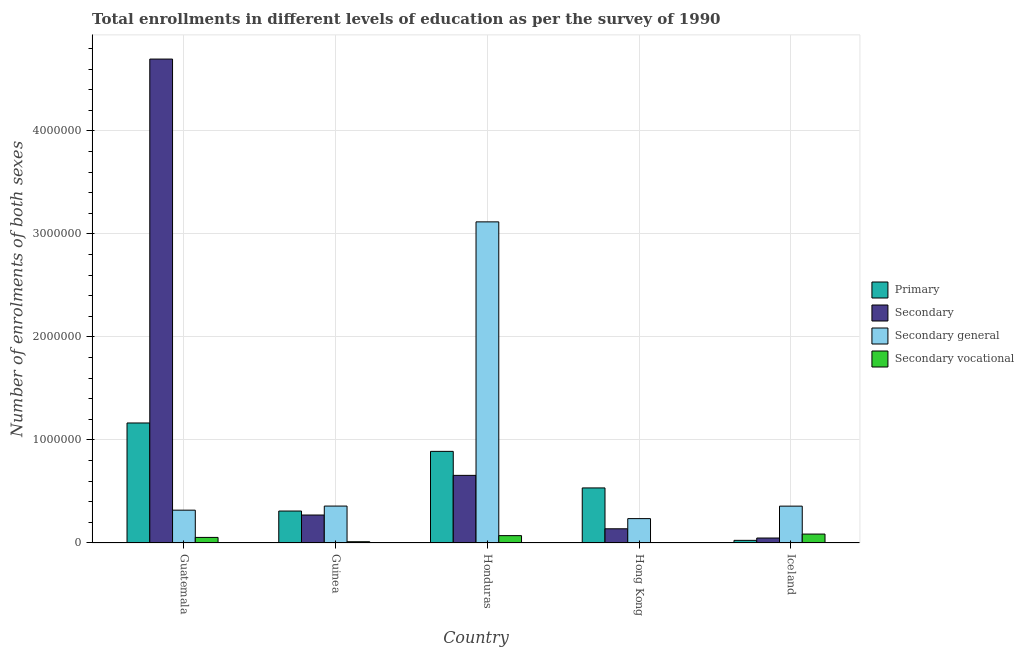How many groups of bars are there?
Provide a succinct answer. 5. Are the number of bars per tick equal to the number of legend labels?
Your response must be concise. Yes. Are the number of bars on each tick of the X-axis equal?
Make the answer very short. Yes. How many bars are there on the 1st tick from the left?
Keep it short and to the point. 4. How many bars are there on the 3rd tick from the right?
Offer a terse response. 4. What is the label of the 2nd group of bars from the left?
Your answer should be compact. Guinea. What is the number of enrolments in secondary education in Honduras?
Your response must be concise. 6.56e+05. Across all countries, what is the maximum number of enrolments in primary education?
Give a very brief answer. 1.16e+06. Across all countries, what is the minimum number of enrolments in secondary education?
Keep it short and to the point. 4.82e+04. In which country was the number of enrolments in secondary education maximum?
Keep it short and to the point. Guatemala. In which country was the number of enrolments in secondary vocational education minimum?
Provide a short and direct response. Hong Kong. What is the total number of enrolments in secondary education in the graph?
Provide a succinct answer. 5.81e+06. What is the difference between the number of enrolments in secondary education in Guatemala and that in Iceland?
Offer a very short reply. 4.65e+06. What is the difference between the number of enrolments in primary education in Honduras and the number of enrolments in secondary general education in Iceland?
Your answer should be compact. 5.32e+05. What is the average number of enrolments in secondary vocational education per country?
Give a very brief answer. 4.52e+04. What is the difference between the number of enrolments in secondary vocational education and number of enrolments in secondary general education in Guatemala?
Provide a succinct answer. -2.65e+05. What is the ratio of the number of enrolments in primary education in Guinea to that in Iceland?
Provide a short and direct response. 12.15. Is the difference between the number of enrolments in primary education in Honduras and Iceland greater than the difference between the number of enrolments in secondary vocational education in Honduras and Iceland?
Your answer should be very brief. Yes. What is the difference between the highest and the second highest number of enrolments in secondary general education?
Give a very brief answer. 2.76e+06. What is the difference between the highest and the lowest number of enrolments in secondary education?
Your response must be concise. 4.65e+06. Is the sum of the number of enrolments in secondary vocational education in Honduras and Hong Kong greater than the maximum number of enrolments in primary education across all countries?
Ensure brevity in your answer.  No. What does the 2nd bar from the left in Iceland represents?
Make the answer very short. Secondary. What does the 4th bar from the right in Honduras represents?
Offer a terse response. Primary. How many bars are there?
Your answer should be compact. 20. Does the graph contain grids?
Offer a very short reply. Yes. Where does the legend appear in the graph?
Your answer should be very brief. Center right. What is the title of the graph?
Keep it short and to the point. Total enrollments in different levels of education as per the survey of 1990. What is the label or title of the X-axis?
Your answer should be very brief. Country. What is the label or title of the Y-axis?
Keep it short and to the point. Number of enrolments of both sexes. What is the Number of enrolments of both sexes of Primary in Guatemala?
Keep it short and to the point. 1.16e+06. What is the Number of enrolments of both sexes of Secondary in Guatemala?
Give a very brief answer. 4.70e+06. What is the Number of enrolments of both sexes of Secondary general in Guatemala?
Your answer should be compact. 3.19e+05. What is the Number of enrolments of both sexes of Secondary vocational in Guatemala?
Provide a succinct answer. 5.41e+04. What is the Number of enrolments of both sexes in Primary in Guinea?
Your answer should be very brief. 3.10e+05. What is the Number of enrolments of both sexes in Secondary in Guinea?
Offer a very short reply. 2.71e+05. What is the Number of enrolments of both sexes in Secondary general in Guinea?
Your answer should be compact. 3.58e+05. What is the Number of enrolments of both sexes of Secondary vocational in Guinea?
Offer a terse response. 1.23e+04. What is the Number of enrolments of both sexes of Primary in Honduras?
Offer a very short reply. 8.89e+05. What is the Number of enrolments of both sexes of Secondary in Honduras?
Make the answer very short. 6.56e+05. What is the Number of enrolments of both sexes in Secondary general in Honduras?
Your response must be concise. 3.12e+06. What is the Number of enrolments of both sexes of Secondary vocational in Honduras?
Your answer should be compact. 7.14e+04. What is the Number of enrolments of both sexes in Primary in Hong Kong?
Provide a succinct answer. 5.34e+05. What is the Number of enrolments of both sexes in Secondary in Hong Kong?
Offer a terse response. 1.38e+05. What is the Number of enrolments of both sexes in Secondary general in Hong Kong?
Provide a succinct answer. 2.37e+05. What is the Number of enrolments of both sexes in Secondary vocational in Hong Kong?
Give a very brief answer. 1906. What is the Number of enrolments of both sexes of Primary in Iceland?
Make the answer very short. 2.55e+04. What is the Number of enrolments of both sexes of Secondary in Iceland?
Offer a terse response. 4.82e+04. What is the Number of enrolments of both sexes of Secondary general in Iceland?
Your answer should be very brief. 3.58e+05. What is the Number of enrolments of both sexes in Secondary vocational in Iceland?
Ensure brevity in your answer.  8.66e+04. Across all countries, what is the maximum Number of enrolments of both sexes in Primary?
Offer a very short reply. 1.16e+06. Across all countries, what is the maximum Number of enrolments of both sexes of Secondary?
Provide a short and direct response. 4.70e+06. Across all countries, what is the maximum Number of enrolments of both sexes of Secondary general?
Your response must be concise. 3.12e+06. Across all countries, what is the maximum Number of enrolments of both sexes of Secondary vocational?
Ensure brevity in your answer.  8.66e+04. Across all countries, what is the minimum Number of enrolments of both sexes in Primary?
Provide a short and direct response. 2.55e+04. Across all countries, what is the minimum Number of enrolments of both sexes of Secondary?
Your answer should be compact. 4.82e+04. Across all countries, what is the minimum Number of enrolments of both sexes in Secondary general?
Make the answer very short. 2.37e+05. Across all countries, what is the minimum Number of enrolments of both sexes of Secondary vocational?
Provide a short and direct response. 1906. What is the total Number of enrolments of both sexes of Primary in the graph?
Give a very brief answer. 2.92e+06. What is the total Number of enrolments of both sexes of Secondary in the graph?
Ensure brevity in your answer.  5.81e+06. What is the total Number of enrolments of both sexes in Secondary general in the graph?
Give a very brief answer. 4.39e+06. What is the total Number of enrolments of both sexes in Secondary vocational in the graph?
Provide a short and direct response. 2.26e+05. What is the difference between the Number of enrolments of both sexes in Primary in Guatemala and that in Guinea?
Your answer should be very brief. 8.55e+05. What is the difference between the Number of enrolments of both sexes of Secondary in Guatemala and that in Guinea?
Provide a short and direct response. 4.43e+06. What is the difference between the Number of enrolments of both sexes of Secondary general in Guatemala and that in Guinea?
Provide a short and direct response. -3.98e+04. What is the difference between the Number of enrolments of both sexes of Secondary vocational in Guatemala and that in Guinea?
Your answer should be compact. 4.18e+04. What is the difference between the Number of enrolments of both sexes in Primary in Guatemala and that in Honduras?
Provide a succinct answer. 2.76e+05. What is the difference between the Number of enrolments of both sexes of Secondary in Guatemala and that in Honduras?
Ensure brevity in your answer.  4.04e+06. What is the difference between the Number of enrolments of both sexes of Secondary general in Guatemala and that in Honduras?
Provide a short and direct response. -2.80e+06. What is the difference between the Number of enrolments of both sexes of Secondary vocational in Guatemala and that in Honduras?
Provide a succinct answer. -1.73e+04. What is the difference between the Number of enrolments of both sexes of Primary in Guatemala and that in Hong Kong?
Your response must be concise. 6.30e+05. What is the difference between the Number of enrolments of both sexes in Secondary in Guatemala and that in Hong Kong?
Your answer should be very brief. 4.56e+06. What is the difference between the Number of enrolments of both sexes of Secondary general in Guatemala and that in Hong Kong?
Keep it short and to the point. 8.20e+04. What is the difference between the Number of enrolments of both sexes of Secondary vocational in Guatemala and that in Hong Kong?
Offer a terse response. 5.22e+04. What is the difference between the Number of enrolments of both sexes in Primary in Guatemala and that in Iceland?
Make the answer very short. 1.14e+06. What is the difference between the Number of enrolments of both sexes of Secondary in Guatemala and that in Iceland?
Your answer should be very brief. 4.65e+06. What is the difference between the Number of enrolments of both sexes of Secondary general in Guatemala and that in Iceland?
Provide a short and direct response. -3.92e+04. What is the difference between the Number of enrolments of both sexes in Secondary vocational in Guatemala and that in Iceland?
Offer a very short reply. -3.25e+04. What is the difference between the Number of enrolments of both sexes in Primary in Guinea and that in Honduras?
Your answer should be very brief. -5.79e+05. What is the difference between the Number of enrolments of both sexes of Secondary in Guinea and that in Honduras?
Offer a terse response. -3.85e+05. What is the difference between the Number of enrolments of both sexes of Secondary general in Guinea and that in Honduras?
Keep it short and to the point. -2.76e+06. What is the difference between the Number of enrolments of both sexes of Secondary vocational in Guinea and that in Honduras?
Provide a succinct answer. -5.91e+04. What is the difference between the Number of enrolments of both sexes of Primary in Guinea and that in Hong Kong?
Your response must be concise. -2.24e+05. What is the difference between the Number of enrolments of both sexes in Secondary in Guinea and that in Hong Kong?
Offer a terse response. 1.34e+05. What is the difference between the Number of enrolments of both sexes of Secondary general in Guinea and that in Hong Kong?
Your response must be concise. 1.22e+05. What is the difference between the Number of enrolments of both sexes of Secondary vocational in Guinea and that in Hong Kong?
Make the answer very short. 1.04e+04. What is the difference between the Number of enrolments of both sexes of Primary in Guinea and that in Iceland?
Offer a terse response. 2.85e+05. What is the difference between the Number of enrolments of both sexes of Secondary in Guinea and that in Iceland?
Provide a short and direct response. 2.23e+05. What is the difference between the Number of enrolments of both sexes of Secondary general in Guinea and that in Iceland?
Provide a succinct answer. 657. What is the difference between the Number of enrolments of both sexes of Secondary vocational in Guinea and that in Iceland?
Offer a terse response. -7.43e+04. What is the difference between the Number of enrolments of both sexes of Primary in Honduras and that in Hong Kong?
Ensure brevity in your answer.  3.55e+05. What is the difference between the Number of enrolments of both sexes of Secondary in Honduras and that in Hong Kong?
Provide a succinct answer. 5.19e+05. What is the difference between the Number of enrolments of both sexes in Secondary general in Honduras and that in Hong Kong?
Make the answer very short. 2.88e+06. What is the difference between the Number of enrolments of both sexes of Secondary vocational in Honduras and that in Hong Kong?
Give a very brief answer. 6.95e+04. What is the difference between the Number of enrolments of both sexes in Primary in Honduras and that in Iceland?
Provide a succinct answer. 8.64e+05. What is the difference between the Number of enrolments of both sexes of Secondary in Honduras and that in Iceland?
Make the answer very short. 6.08e+05. What is the difference between the Number of enrolments of both sexes of Secondary general in Honduras and that in Iceland?
Offer a very short reply. 2.76e+06. What is the difference between the Number of enrolments of both sexes in Secondary vocational in Honduras and that in Iceland?
Offer a terse response. -1.52e+04. What is the difference between the Number of enrolments of both sexes in Primary in Hong Kong and that in Iceland?
Provide a short and direct response. 5.09e+05. What is the difference between the Number of enrolments of both sexes of Secondary in Hong Kong and that in Iceland?
Give a very brief answer. 8.97e+04. What is the difference between the Number of enrolments of both sexes of Secondary general in Hong Kong and that in Iceland?
Make the answer very short. -1.21e+05. What is the difference between the Number of enrolments of both sexes of Secondary vocational in Hong Kong and that in Iceland?
Give a very brief answer. -8.47e+04. What is the difference between the Number of enrolments of both sexes in Primary in Guatemala and the Number of enrolments of both sexes in Secondary in Guinea?
Make the answer very short. 8.94e+05. What is the difference between the Number of enrolments of both sexes of Primary in Guatemala and the Number of enrolments of both sexes of Secondary general in Guinea?
Keep it short and to the point. 8.07e+05. What is the difference between the Number of enrolments of both sexes of Primary in Guatemala and the Number of enrolments of both sexes of Secondary vocational in Guinea?
Your answer should be compact. 1.15e+06. What is the difference between the Number of enrolments of both sexes in Secondary in Guatemala and the Number of enrolments of both sexes in Secondary general in Guinea?
Give a very brief answer. 4.34e+06. What is the difference between the Number of enrolments of both sexes in Secondary in Guatemala and the Number of enrolments of both sexes in Secondary vocational in Guinea?
Your answer should be compact. 4.69e+06. What is the difference between the Number of enrolments of both sexes of Secondary general in Guatemala and the Number of enrolments of both sexes of Secondary vocational in Guinea?
Ensure brevity in your answer.  3.06e+05. What is the difference between the Number of enrolments of both sexes in Primary in Guatemala and the Number of enrolments of both sexes in Secondary in Honduras?
Ensure brevity in your answer.  5.09e+05. What is the difference between the Number of enrolments of both sexes of Primary in Guatemala and the Number of enrolments of both sexes of Secondary general in Honduras?
Ensure brevity in your answer.  -1.95e+06. What is the difference between the Number of enrolments of both sexes of Primary in Guatemala and the Number of enrolments of both sexes of Secondary vocational in Honduras?
Keep it short and to the point. 1.09e+06. What is the difference between the Number of enrolments of both sexes in Secondary in Guatemala and the Number of enrolments of both sexes in Secondary general in Honduras?
Your response must be concise. 1.58e+06. What is the difference between the Number of enrolments of both sexes in Secondary in Guatemala and the Number of enrolments of both sexes in Secondary vocational in Honduras?
Offer a terse response. 4.63e+06. What is the difference between the Number of enrolments of both sexes of Secondary general in Guatemala and the Number of enrolments of both sexes of Secondary vocational in Honduras?
Offer a very short reply. 2.47e+05. What is the difference between the Number of enrolments of both sexes of Primary in Guatemala and the Number of enrolments of both sexes of Secondary in Hong Kong?
Give a very brief answer. 1.03e+06. What is the difference between the Number of enrolments of both sexes of Primary in Guatemala and the Number of enrolments of both sexes of Secondary general in Hong Kong?
Provide a short and direct response. 9.28e+05. What is the difference between the Number of enrolments of both sexes in Primary in Guatemala and the Number of enrolments of both sexes in Secondary vocational in Hong Kong?
Make the answer very short. 1.16e+06. What is the difference between the Number of enrolments of both sexes of Secondary in Guatemala and the Number of enrolments of both sexes of Secondary general in Hong Kong?
Offer a very short reply. 4.46e+06. What is the difference between the Number of enrolments of both sexes of Secondary in Guatemala and the Number of enrolments of both sexes of Secondary vocational in Hong Kong?
Provide a succinct answer. 4.70e+06. What is the difference between the Number of enrolments of both sexes in Secondary general in Guatemala and the Number of enrolments of both sexes in Secondary vocational in Hong Kong?
Your response must be concise. 3.17e+05. What is the difference between the Number of enrolments of both sexes of Primary in Guatemala and the Number of enrolments of both sexes of Secondary in Iceland?
Provide a short and direct response. 1.12e+06. What is the difference between the Number of enrolments of both sexes of Primary in Guatemala and the Number of enrolments of both sexes of Secondary general in Iceland?
Make the answer very short. 8.07e+05. What is the difference between the Number of enrolments of both sexes of Primary in Guatemala and the Number of enrolments of both sexes of Secondary vocational in Iceland?
Keep it short and to the point. 1.08e+06. What is the difference between the Number of enrolments of both sexes in Secondary in Guatemala and the Number of enrolments of both sexes in Secondary general in Iceland?
Your answer should be very brief. 4.34e+06. What is the difference between the Number of enrolments of both sexes in Secondary in Guatemala and the Number of enrolments of both sexes in Secondary vocational in Iceland?
Offer a very short reply. 4.61e+06. What is the difference between the Number of enrolments of both sexes of Secondary general in Guatemala and the Number of enrolments of both sexes of Secondary vocational in Iceland?
Your response must be concise. 2.32e+05. What is the difference between the Number of enrolments of both sexes of Primary in Guinea and the Number of enrolments of both sexes of Secondary in Honduras?
Provide a short and direct response. -3.46e+05. What is the difference between the Number of enrolments of both sexes in Primary in Guinea and the Number of enrolments of both sexes in Secondary general in Honduras?
Make the answer very short. -2.81e+06. What is the difference between the Number of enrolments of both sexes of Primary in Guinea and the Number of enrolments of both sexes of Secondary vocational in Honduras?
Give a very brief answer. 2.39e+05. What is the difference between the Number of enrolments of both sexes in Secondary in Guinea and the Number of enrolments of both sexes in Secondary general in Honduras?
Your answer should be very brief. -2.85e+06. What is the difference between the Number of enrolments of both sexes of Secondary in Guinea and the Number of enrolments of both sexes of Secondary vocational in Honduras?
Provide a succinct answer. 2.00e+05. What is the difference between the Number of enrolments of both sexes in Secondary general in Guinea and the Number of enrolments of both sexes in Secondary vocational in Honduras?
Your answer should be very brief. 2.87e+05. What is the difference between the Number of enrolments of both sexes of Primary in Guinea and the Number of enrolments of both sexes of Secondary in Hong Kong?
Your answer should be very brief. 1.72e+05. What is the difference between the Number of enrolments of both sexes in Primary in Guinea and the Number of enrolments of both sexes in Secondary general in Hong Kong?
Make the answer very short. 7.35e+04. What is the difference between the Number of enrolments of both sexes of Primary in Guinea and the Number of enrolments of both sexes of Secondary vocational in Hong Kong?
Give a very brief answer. 3.08e+05. What is the difference between the Number of enrolments of both sexes in Secondary in Guinea and the Number of enrolments of both sexes in Secondary general in Hong Kong?
Your answer should be compact. 3.48e+04. What is the difference between the Number of enrolments of both sexes of Secondary in Guinea and the Number of enrolments of both sexes of Secondary vocational in Hong Kong?
Ensure brevity in your answer.  2.70e+05. What is the difference between the Number of enrolments of both sexes of Secondary general in Guinea and the Number of enrolments of both sexes of Secondary vocational in Hong Kong?
Make the answer very short. 3.57e+05. What is the difference between the Number of enrolments of both sexes of Primary in Guinea and the Number of enrolments of both sexes of Secondary in Iceland?
Your response must be concise. 2.62e+05. What is the difference between the Number of enrolments of both sexes in Primary in Guinea and the Number of enrolments of both sexes in Secondary general in Iceland?
Give a very brief answer. -4.77e+04. What is the difference between the Number of enrolments of both sexes in Primary in Guinea and the Number of enrolments of both sexes in Secondary vocational in Iceland?
Offer a terse response. 2.23e+05. What is the difference between the Number of enrolments of both sexes of Secondary in Guinea and the Number of enrolments of both sexes of Secondary general in Iceland?
Your answer should be compact. -8.63e+04. What is the difference between the Number of enrolments of both sexes of Secondary in Guinea and the Number of enrolments of both sexes of Secondary vocational in Iceland?
Give a very brief answer. 1.85e+05. What is the difference between the Number of enrolments of both sexes of Secondary general in Guinea and the Number of enrolments of both sexes of Secondary vocational in Iceland?
Provide a short and direct response. 2.72e+05. What is the difference between the Number of enrolments of both sexes in Primary in Honduras and the Number of enrolments of both sexes in Secondary in Hong Kong?
Make the answer very short. 7.51e+05. What is the difference between the Number of enrolments of both sexes in Primary in Honduras and the Number of enrolments of both sexes in Secondary general in Hong Kong?
Provide a succinct answer. 6.53e+05. What is the difference between the Number of enrolments of both sexes in Primary in Honduras and the Number of enrolments of both sexes in Secondary vocational in Hong Kong?
Offer a terse response. 8.87e+05. What is the difference between the Number of enrolments of both sexes of Secondary in Honduras and the Number of enrolments of both sexes of Secondary general in Hong Kong?
Give a very brief answer. 4.20e+05. What is the difference between the Number of enrolments of both sexes in Secondary in Honduras and the Number of enrolments of both sexes in Secondary vocational in Hong Kong?
Ensure brevity in your answer.  6.54e+05. What is the difference between the Number of enrolments of both sexes of Secondary general in Honduras and the Number of enrolments of both sexes of Secondary vocational in Hong Kong?
Offer a very short reply. 3.12e+06. What is the difference between the Number of enrolments of both sexes in Primary in Honduras and the Number of enrolments of both sexes in Secondary in Iceland?
Ensure brevity in your answer.  8.41e+05. What is the difference between the Number of enrolments of both sexes of Primary in Honduras and the Number of enrolments of both sexes of Secondary general in Iceland?
Keep it short and to the point. 5.32e+05. What is the difference between the Number of enrolments of both sexes in Primary in Honduras and the Number of enrolments of both sexes in Secondary vocational in Iceland?
Offer a terse response. 8.03e+05. What is the difference between the Number of enrolments of both sexes in Secondary in Honduras and the Number of enrolments of both sexes in Secondary general in Iceland?
Give a very brief answer. 2.99e+05. What is the difference between the Number of enrolments of both sexes of Secondary in Honduras and the Number of enrolments of both sexes of Secondary vocational in Iceland?
Your answer should be very brief. 5.70e+05. What is the difference between the Number of enrolments of both sexes of Secondary general in Honduras and the Number of enrolments of both sexes of Secondary vocational in Iceland?
Offer a very short reply. 3.03e+06. What is the difference between the Number of enrolments of both sexes in Primary in Hong Kong and the Number of enrolments of both sexes in Secondary in Iceland?
Give a very brief answer. 4.86e+05. What is the difference between the Number of enrolments of both sexes in Primary in Hong Kong and the Number of enrolments of both sexes in Secondary general in Iceland?
Make the answer very short. 1.77e+05. What is the difference between the Number of enrolments of both sexes of Primary in Hong Kong and the Number of enrolments of both sexes of Secondary vocational in Iceland?
Ensure brevity in your answer.  4.48e+05. What is the difference between the Number of enrolments of both sexes in Secondary in Hong Kong and the Number of enrolments of both sexes in Secondary general in Iceland?
Your response must be concise. -2.20e+05. What is the difference between the Number of enrolments of both sexes in Secondary in Hong Kong and the Number of enrolments of both sexes in Secondary vocational in Iceland?
Offer a terse response. 5.13e+04. What is the difference between the Number of enrolments of both sexes of Secondary general in Hong Kong and the Number of enrolments of both sexes of Secondary vocational in Iceland?
Keep it short and to the point. 1.50e+05. What is the average Number of enrolments of both sexes in Primary per country?
Provide a succinct answer. 5.85e+05. What is the average Number of enrolments of both sexes in Secondary per country?
Give a very brief answer. 1.16e+06. What is the average Number of enrolments of both sexes of Secondary general per country?
Keep it short and to the point. 8.78e+05. What is the average Number of enrolments of both sexes of Secondary vocational per country?
Offer a very short reply. 4.52e+04. What is the difference between the Number of enrolments of both sexes in Primary and Number of enrolments of both sexes in Secondary in Guatemala?
Keep it short and to the point. -3.53e+06. What is the difference between the Number of enrolments of both sexes in Primary and Number of enrolments of both sexes in Secondary general in Guatemala?
Your answer should be very brief. 8.46e+05. What is the difference between the Number of enrolments of both sexes of Primary and Number of enrolments of both sexes of Secondary vocational in Guatemala?
Ensure brevity in your answer.  1.11e+06. What is the difference between the Number of enrolments of both sexes of Secondary and Number of enrolments of both sexes of Secondary general in Guatemala?
Your response must be concise. 4.38e+06. What is the difference between the Number of enrolments of both sexes in Secondary and Number of enrolments of both sexes in Secondary vocational in Guatemala?
Provide a short and direct response. 4.64e+06. What is the difference between the Number of enrolments of both sexes in Secondary general and Number of enrolments of both sexes in Secondary vocational in Guatemala?
Provide a succinct answer. 2.65e+05. What is the difference between the Number of enrolments of both sexes in Primary and Number of enrolments of both sexes in Secondary in Guinea?
Ensure brevity in your answer.  3.86e+04. What is the difference between the Number of enrolments of both sexes in Primary and Number of enrolments of both sexes in Secondary general in Guinea?
Make the answer very short. -4.83e+04. What is the difference between the Number of enrolments of both sexes in Primary and Number of enrolments of both sexes in Secondary vocational in Guinea?
Ensure brevity in your answer.  2.98e+05. What is the difference between the Number of enrolments of both sexes in Secondary and Number of enrolments of both sexes in Secondary general in Guinea?
Your response must be concise. -8.70e+04. What is the difference between the Number of enrolments of both sexes in Secondary and Number of enrolments of both sexes in Secondary vocational in Guinea?
Offer a terse response. 2.59e+05. What is the difference between the Number of enrolments of both sexes of Secondary general and Number of enrolments of both sexes of Secondary vocational in Guinea?
Make the answer very short. 3.46e+05. What is the difference between the Number of enrolments of both sexes in Primary and Number of enrolments of both sexes in Secondary in Honduras?
Keep it short and to the point. 2.33e+05. What is the difference between the Number of enrolments of both sexes in Primary and Number of enrolments of both sexes in Secondary general in Honduras?
Make the answer very short. -2.23e+06. What is the difference between the Number of enrolments of both sexes in Primary and Number of enrolments of both sexes in Secondary vocational in Honduras?
Your response must be concise. 8.18e+05. What is the difference between the Number of enrolments of both sexes in Secondary and Number of enrolments of both sexes in Secondary general in Honduras?
Offer a very short reply. -2.46e+06. What is the difference between the Number of enrolments of both sexes in Secondary and Number of enrolments of both sexes in Secondary vocational in Honduras?
Your answer should be very brief. 5.85e+05. What is the difference between the Number of enrolments of both sexes in Secondary general and Number of enrolments of both sexes in Secondary vocational in Honduras?
Your answer should be very brief. 3.05e+06. What is the difference between the Number of enrolments of both sexes in Primary and Number of enrolments of both sexes in Secondary in Hong Kong?
Your response must be concise. 3.97e+05. What is the difference between the Number of enrolments of both sexes of Primary and Number of enrolments of both sexes of Secondary general in Hong Kong?
Give a very brief answer. 2.98e+05. What is the difference between the Number of enrolments of both sexes in Primary and Number of enrolments of both sexes in Secondary vocational in Hong Kong?
Provide a succinct answer. 5.33e+05. What is the difference between the Number of enrolments of both sexes of Secondary and Number of enrolments of both sexes of Secondary general in Hong Kong?
Provide a short and direct response. -9.87e+04. What is the difference between the Number of enrolments of both sexes in Secondary and Number of enrolments of both sexes in Secondary vocational in Hong Kong?
Ensure brevity in your answer.  1.36e+05. What is the difference between the Number of enrolments of both sexes in Secondary general and Number of enrolments of both sexes in Secondary vocational in Hong Kong?
Your answer should be very brief. 2.35e+05. What is the difference between the Number of enrolments of both sexes of Primary and Number of enrolments of both sexes of Secondary in Iceland?
Make the answer very short. -2.27e+04. What is the difference between the Number of enrolments of both sexes of Primary and Number of enrolments of both sexes of Secondary general in Iceland?
Your answer should be very brief. -3.32e+05. What is the difference between the Number of enrolments of both sexes of Primary and Number of enrolments of both sexes of Secondary vocational in Iceland?
Ensure brevity in your answer.  -6.11e+04. What is the difference between the Number of enrolments of both sexes in Secondary and Number of enrolments of both sexes in Secondary general in Iceland?
Provide a succinct answer. -3.10e+05. What is the difference between the Number of enrolments of both sexes in Secondary and Number of enrolments of both sexes in Secondary vocational in Iceland?
Ensure brevity in your answer.  -3.84e+04. What is the difference between the Number of enrolments of both sexes in Secondary general and Number of enrolments of both sexes in Secondary vocational in Iceland?
Keep it short and to the point. 2.71e+05. What is the ratio of the Number of enrolments of both sexes in Primary in Guatemala to that in Guinea?
Your answer should be very brief. 3.76. What is the ratio of the Number of enrolments of both sexes in Secondary in Guatemala to that in Guinea?
Provide a short and direct response. 17.31. What is the ratio of the Number of enrolments of both sexes in Secondary general in Guatemala to that in Guinea?
Ensure brevity in your answer.  0.89. What is the ratio of the Number of enrolments of both sexes in Secondary vocational in Guatemala to that in Guinea?
Your answer should be compact. 4.41. What is the ratio of the Number of enrolments of both sexes of Primary in Guatemala to that in Honduras?
Provide a short and direct response. 1.31. What is the ratio of the Number of enrolments of both sexes in Secondary in Guatemala to that in Honduras?
Keep it short and to the point. 7.16. What is the ratio of the Number of enrolments of both sexes in Secondary general in Guatemala to that in Honduras?
Offer a terse response. 0.1. What is the ratio of the Number of enrolments of both sexes in Secondary vocational in Guatemala to that in Honduras?
Your answer should be compact. 0.76. What is the ratio of the Number of enrolments of both sexes in Primary in Guatemala to that in Hong Kong?
Keep it short and to the point. 2.18. What is the ratio of the Number of enrolments of both sexes of Secondary in Guatemala to that in Hong Kong?
Keep it short and to the point. 34.06. What is the ratio of the Number of enrolments of both sexes in Secondary general in Guatemala to that in Hong Kong?
Provide a short and direct response. 1.35. What is the ratio of the Number of enrolments of both sexes in Secondary vocational in Guatemala to that in Hong Kong?
Your answer should be very brief. 28.38. What is the ratio of the Number of enrolments of both sexes of Primary in Guatemala to that in Iceland?
Provide a succinct answer. 45.64. What is the ratio of the Number of enrolments of both sexes of Secondary in Guatemala to that in Iceland?
Make the answer very short. 97.44. What is the ratio of the Number of enrolments of both sexes of Secondary general in Guatemala to that in Iceland?
Give a very brief answer. 0.89. What is the ratio of the Number of enrolments of both sexes in Secondary vocational in Guatemala to that in Iceland?
Provide a succinct answer. 0.62. What is the ratio of the Number of enrolments of both sexes in Primary in Guinea to that in Honduras?
Provide a succinct answer. 0.35. What is the ratio of the Number of enrolments of both sexes in Secondary in Guinea to that in Honduras?
Make the answer very short. 0.41. What is the ratio of the Number of enrolments of both sexes in Secondary general in Guinea to that in Honduras?
Ensure brevity in your answer.  0.12. What is the ratio of the Number of enrolments of both sexes of Secondary vocational in Guinea to that in Honduras?
Provide a succinct answer. 0.17. What is the ratio of the Number of enrolments of both sexes of Primary in Guinea to that in Hong Kong?
Ensure brevity in your answer.  0.58. What is the ratio of the Number of enrolments of both sexes in Secondary in Guinea to that in Hong Kong?
Ensure brevity in your answer.  1.97. What is the ratio of the Number of enrolments of both sexes in Secondary general in Guinea to that in Hong Kong?
Offer a terse response. 1.51. What is the ratio of the Number of enrolments of both sexes of Secondary vocational in Guinea to that in Hong Kong?
Your answer should be compact. 6.43. What is the ratio of the Number of enrolments of both sexes of Primary in Guinea to that in Iceland?
Offer a terse response. 12.15. What is the ratio of the Number of enrolments of both sexes of Secondary in Guinea to that in Iceland?
Keep it short and to the point. 5.63. What is the ratio of the Number of enrolments of both sexes of Secondary vocational in Guinea to that in Iceland?
Offer a very short reply. 0.14. What is the ratio of the Number of enrolments of both sexes in Primary in Honduras to that in Hong Kong?
Ensure brevity in your answer.  1.66. What is the ratio of the Number of enrolments of both sexes of Secondary in Honduras to that in Hong Kong?
Provide a succinct answer. 4.76. What is the ratio of the Number of enrolments of both sexes in Secondary general in Honduras to that in Hong Kong?
Make the answer very short. 13.18. What is the ratio of the Number of enrolments of both sexes of Secondary vocational in Honduras to that in Hong Kong?
Your response must be concise. 37.46. What is the ratio of the Number of enrolments of both sexes in Primary in Honduras to that in Iceland?
Your response must be concise. 34.84. What is the ratio of the Number of enrolments of both sexes of Secondary in Honduras to that in Iceland?
Offer a terse response. 13.62. What is the ratio of the Number of enrolments of both sexes of Secondary general in Honduras to that in Iceland?
Your answer should be compact. 8.71. What is the ratio of the Number of enrolments of both sexes in Secondary vocational in Honduras to that in Iceland?
Your response must be concise. 0.82. What is the ratio of the Number of enrolments of both sexes in Primary in Hong Kong to that in Iceland?
Provide a short and direct response. 20.94. What is the ratio of the Number of enrolments of both sexes of Secondary in Hong Kong to that in Iceland?
Your answer should be very brief. 2.86. What is the ratio of the Number of enrolments of both sexes of Secondary general in Hong Kong to that in Iceland?
Your response must be concise. 0.66. What is the ratio of the Number of enrolments of both sexes of Secondary vocational in Hong Kong to that in Iceland?
Your answer should be very brief. 0.02. What is the difference between the highest and the second highest Number of enrolments of both sexes in Primary?
Your response must be concise. 2.76e+05. What is the difference between the highest and the second highest Number of enrolments of both sexes of Secondary?
Your response must be concise. 4.04e+06. What is the difference between the highest and the second highest Number of enrolments of both sexes of Secondary general?
Offer a terse response. 2.76e+06. What is the difference between the highest and the second highest Number of enrolments of both sexes of Secondary vocational?
Your answer should be very brief. 1.52e+04. What is the difference between the highest and the lowest Number of enrolments of both sexes of Primary?
Offer a terse response. 1.14e+06. What is the difference between the highest and the lowest Number of enrolments of both sexes of Secondary?
Your answer should be very brief. 4.65e+06. What is the difference between the highest and the lowest Number of enrolments of both sexes in Secondary general?
Your response must be concise. 2.88e+06. What is the difference between the highest and the lowest Number of enrolments of both sexes in Secondary vocational?
Make the answer very short. 8.47e+04. 